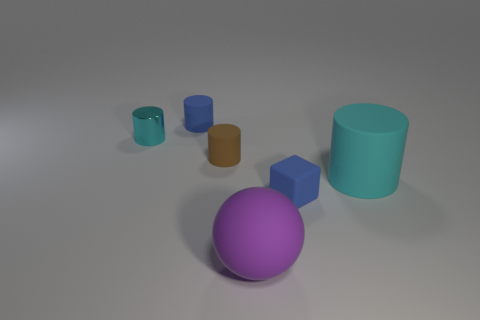How many things have the same color as the cube?
Make the answer very short. 1. Is the color of the cylinder that is on the left side of the tiny blue rubber cylinder the same as the big cylinder?
Make the answer very short. Yes. There is a cyan object that is right of the ball; what shape is it?
Offer a terse response. Cylinder. Is there a cube that is to the left of the small blue object in front of the big cyan matte object?
Provide a succinct answer. No. What number of large green cylinders are the same material as the block?
Provide a succinct answer. 0. What is the size of the blue thing that is behind the rubber cylinder that is on the right side of the small cylinder that is right of the blue rubber cylinder?
Keep it short and to the point. Small. How many tiny blue rubber cylinders are in front of the blue rubber cylinder?
Offer a terse response. 0. Is the number of cyan matte balls greater than the number of small blue matte cylinders?
Give a very brief answer. No. What size is the rubber thing that is the same color as the matte cube?
Your response must be concise. Small. How big is the thing that is both in front of the big cyan rubber cylinder and behind the large ball?
Provide a short and direct response. Small. 